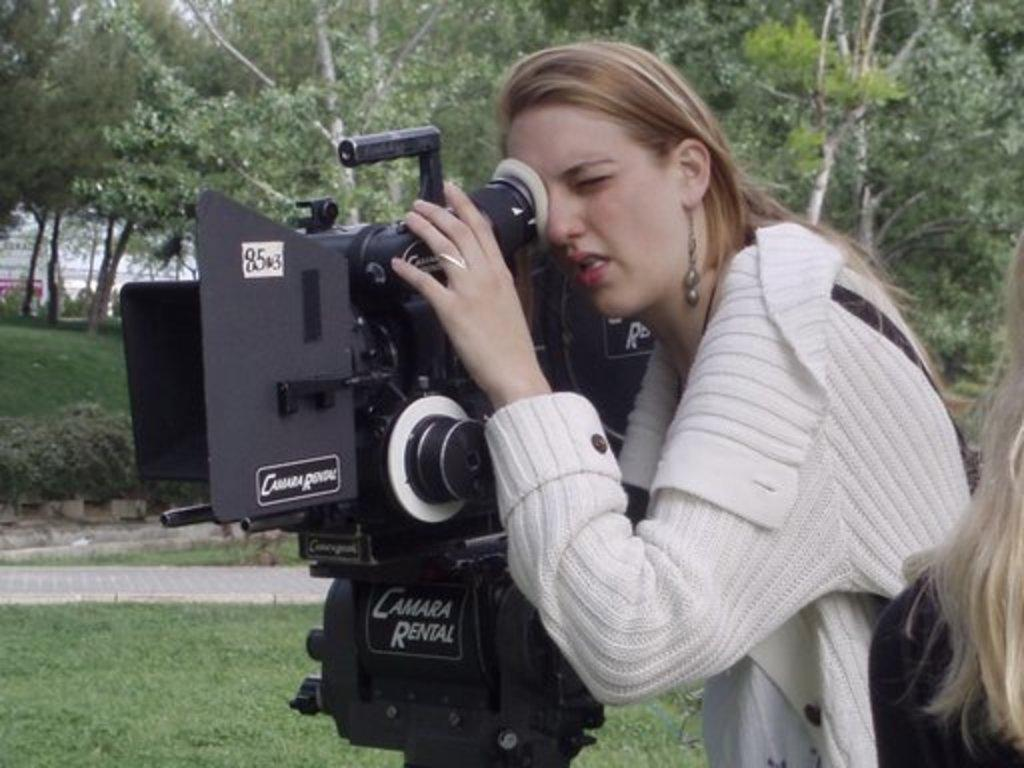What is the main subject of the image? There is a person in the image. What is the person wearing? The person is wearing a white dress. What is the person doing in the image? The person watching into a camera. Where is the camera located? The camera is on the grass. What can be seen in the background of the image? There are trees behind the person. What type of whip is being used to make a discovery in the image? There is no whip or discovery present in the image. 